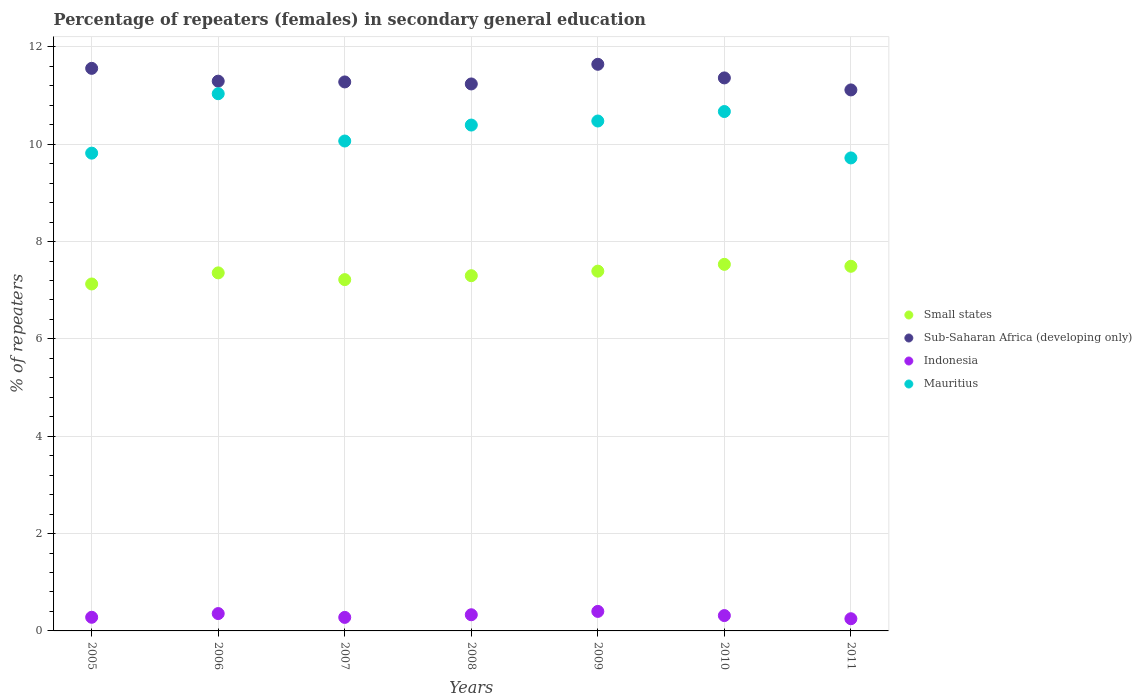Is the number of dotlines equal to the number of legend labels?
Provide a succinct answer. Yes. What is the percentage of female repeaters in Small states in 2005?
Your answer should be compact. 7.13. Across all years, what is the maximum percentage of female repeaters in Sub-Saharan Africa (developing only)?
Your response must be concise. 11.64. Across all years, what is the minimum percentage of female repeaters in Small states?
Make the answer very short. 7.13. In which year was the percentage of female repeaters in Sub-Saharan Africa (developing only) minimum?
Provide a short and direct response. 2011. What is the total percentage of female repeaters in Small states in the graph?
Offer a very short reply. 51.42. What is the difference between the percentage of female repeaters in Sub-Saharan Africa (developing only) in 2009 and that in 2011?
Ensure brevity in your answer.  0.53. What is the difference between the percentage of female repeaters in Small states in 2005 and the percentage of female repeaters in Mauritius in 2010?
Provide a succinct answer. -3.54. What is the average percentage of female repeaters in Mauritius per year?
Keep it short and to the point. 10.31. In the year 2007, what is the difference between the percentage of female repeaters in Small states and percentage of female repeaters in Mauritius?
Your answer should be very brief. -2.85. In how many years, is the percentage of female repeaters in Mauritius greater than 7.6 %?
Your response must be concise. 7. What is the ratio of the percentage of female repeaters in Small states in 2005 to that in 2007?
Give a very brief answer. 0.99. Is the percentage of female repeaters in Sub-Saharan Africa (developing only) in 2005 less than that in 2008?
Ensure brevity in your answer.  No. What is the difference between the highest and the second highest percentage of female repeaters in Sub-Saharan Africa (developing only)?
Make the answer very short. 0.08. What is the difference between the highest and the lowest percentage of female repeaters in Mauritius?
Offer a very short reply. 1.32. In how many years, is the percentage of female repeaters in Mauritius greater than the average percentage of female repeaters in Mauritius taken over all years?
Your response must be concise. 4. Is the percentage of female repeaters in Small states strictly greater than the percentage of female repeaters in Sub-Saharan Africa (developing only) over the years?
Your response must be concise. No. Is the percentage of female repeaters in Mauritius strictly less than the percentage of female repeaters in Indonesia over the years?
Give a very brief answer. No. How many dotlines are there?
Ensure brevity in your answer.  4. How many years are there in the graph?
Provide a succinct answer. 7. Are the values on the major ticks of Y-axis written in scientific E-notation?
Ensure brevity in your answer.  No. How are the legend labels stacked?
Give a very brief answer. Vertical. What is the title of the graph?
Ensure brevity in your answer.  Percentage of repeaters (females) in secondary general education. Does "High income: nonOECD" appear as one of the legend labels in the graph?
Your answer should be very brief. No. What is the label or title of the Y-axis?
Ensure brevity in your answer.  % of repeaters. What is the % of repeaters of Small states in 2005?
Provide a succinct answer. 7.13. What is the % of repeaters in Sub-Saharan Africa (developing only) in 2005?
Give a very brief answer. 11.56. What is the % of repeaters in Indonesia in 2005?
Offer a very short reply. 0.28. What is the % of repeaters of Mauritius in 2005?
Give a very brief answer. 9.82. What is the % of repeaters of Small states in 2006?
Keep it short and to the point. 7.36. What is the % of repeaters of Sub-Saharan Africa (developing only) in 2006?
Offer a very short reply. 11.3. What is the % of repeaters of Indonesia in 2006?
Make the answer very short. 0.36. What is the % of repeaters of Mauritius in 2006?
Ensure brevity in your answer.  11.04. What is the % of repeaters of Small states in 2007?
Make the answer very short. 7.22. What is the % of repeaters of Sub-Saharan Africa (developing only) in 2007?
Offer a terse response. 11.28. What is the % of repeaters in Indonesia in 2007?
Provide a succinct answer. 0.28. What is the % of repeaters in Mauritius in 2007?
Provide a succinct answer. 10.07. What is the % of repeaters in Small states in 2008?
Offer a very short reply. 7.3. What is the % of repeaters in Sub-Saharan Africa (developing only) in 2008?
Provide a short and direct response. 11.24. What is the % of repeaters in Indonesia in 2008?
Provide a short and direct response. 0.33. What is the % of repeaters of Mauritius in 2008?
Provide a succinct answer. 10.39. What is the % of repeaters of Small states in 2009?
Provide a short and direct response. 7.39. What is the % of repeaters of Sub-Saharan Africa (developing only) in 2009?
Offer a terse response. 11.64. What is the % of repeaters of Indonesia in 2009?
Your response must be concise. 0.4. What is the % of repeaters of Mauritius in 2009?
Your answer should be compact. 10.48. What is the % of repeaters of Small states in 2010?
Your response must be concise. 7.53. What is the % of repeaters in Sub-Saharan Africa (developing only) in 2010?
Your answer should be compact. 11.36. What is the % of repeaters of Indonesia in 2010?
Provide a short and direct response. 0.32. What is the % of repeaters in Mauritius in 2010?
Give a very brief answer. 10.67. What is the % of repeaters in Small states in 2011?
Your answer should be very brief. 7.49. What is the % of repeaters of Sub-Saharan Africa (developing only) in 2011?
Provide a short and direct response. 11.12. What is the % of repeaters of Indonesia in 2011?
Offer a very short reply. 0.25. What is the % of repeaters in Mauritius in 2011?
Keep it short and to the point. 9.72. Across all years, what is the maximum % of repeaters of Small states?
Give a very brief answer. 7.53. Across all years, what is the maximum % of repeaters of Sub-Saharan Africa (developing only)?
Your answer should be compact. 11.64. Across all years, what is the maximum % of repeaters in Indonesia?
Make the answer very short. 0.4. Across all years, what is the maximum % of repeaters of Mauritius?
Your answer should be very brief. 11.04. Across all years, what is the minimum % of repeaters of Small states?
Keep it short and to the point. 7.13. Across all years, what is the minimum % of repeaters in Sub-Saharan Africa (developing only)?
Your answer should be compact. 11.12. Across all years, what is the minimum % of repeaters of Indonesia?
Offer a terse response. 0.25. Across all years, what is the minimum % of repeaters of Mauritius?
Your answer should be very brief. 9.72. What is the total % of repeaters in Small states in the graph?
Ensure brevity in your answer.  51.42. What is the total % of repeaters in Sub-Saharan Africa (developing only) in the graph?
Your answer should be compact. 79.5. What is the total % of repeaters of Indonesia in the graph?
Give a very brief answer. 2.21. What is the total % of repeaters in Mauritius in the graph?
Your response must be concise. 72.18. What is the difference between the % of repeaters in Small states in 2005 and that in 2006?
Offer a terse response. -0.23. What is the difference between the % of repeaters in Sub-Saharan Africa (developing only) in 2005 and that in 2006?
Offer a very short reply. 0.26. What is the difference between the % of repeaters in Indonesia in 2005 and that in 2006?
Ensure brevity in your answer.  -0.08. What is the difference between the % of repeaters of Mauritius in 2005 and that in 2006?
Offer a terse response. -1.22. What is the difference between the % of repeaters of Small states in 2005 and that in 2007?
Give a very brief answer. -0.09. What is the difference between the % of repeaters of Sub-Saharan Africa (developing only) in 2005 and that in 2007?
Offer a terse response. 0.28. What is the difference between the % of repeaters of Indonesia in 2005 and that in 2007?
Offer a terse response. 0. What is the difference between the % of repeaters in Mauritius in 2005 and that in 2007?
Offer a terse response. -0.25. What is the difference between the % of repeaters of Small states in 2005 and that in 2008?
Ensure brevity in your answer.  -0.17. What is the difference between the % of repeaters in Sub-Saharan Africa (developing only) in 2005 and that in 2008?
Your answer should be compact. 0.32. What is the difference between the % of repeaters in Indonesia in 2005 and that in 2008?
Offer a terse response. -0.05. What is the difference between the % of repeaters in Mauritius in 2005 and that in 2008?
Ensure brevity in your answer.  -0.58. What is the difference between the % of repeaters of Small states in 2005 and that in 2009?
Offer a terse response. -0.26. What is the difference between the % of repeaters in Sub-Saharan Africa (developing only) in 2005 and that in 2009?
Provide a short and direct response. -0.08. What is the difference between the % of repeaters in Indonesia in 2005 and that in 2009?
Offer a very short reply. -0.12. What is the difference between the % of repeaters in Mauritius in 2005 and that in 2009?
Offer a terse response. -0.66. What is the difference between the % of repeaters of Small states in 2005 and that in 2010?
Offer a very short reply. -0.4. What is the difference between the % of repeaters in Sub-Saharan Africa (developing only) in 2005 and that in 2010?
Keep it short and to the point. 0.2. What is the difference between the % of repeaters of Indonesia in 2005 and that in 2010?
Offer a terse response. -0.03. What is the difference between the % of repeaters in Mauritius in 2005 and that in 2010?
Make the answer very short. -0.86. What is the difference between the % of repeaters of Small states in 2005 and that in 2011?
Your response must be concise. -0.36. What is the difference between the % of repeaters of Sub-Saharan Africa (developing only) in 2005 and that in 2011?
Your response must be concise. 0.44. What is the difference between the % of repeaters in Indonesia in 2005 and that in 2011?
Offer a terse response. 0.03. What is the difference between the % of repeaters in Mauritius in 2005 and that in 2011?
Your answer should be compact. 0.1. What is the difference between the % of repeaters in Small states in 2006 and that in 2007?
Provide a succinct answer. 0.14. What is the difference between the % of repeaters of Sub-Saharan Africa (developing only) in 2006 and that in 2007?
Provide a short and direct response. 0.02. What is the difference between the % of repeaters in Indonesia in 2006 and that in 2007?
Your answer should be compact. 0.08. What is the difference between the % of repeaters in Small states in 2006 and that in 2008?
Your answer should be compact. 0.06. What is the difference between the % of repeaters of Sub-Saharan Africa (developing only) in 2006 and that in 2008?
Keep it short and to the point. 0.06. What is the difference between the % of repeaters in Indonesia in 2006 and that in 2008?
Make the answer very short. 0.02. What is the difference between the % of repeaters in Mauritius in 2006 and that in 2008?
Offer a very short reply. 0.64. What is the difference between the % of repeaters in Small states in 2006 and that in 2009?
Your answer should be very brief. -0.04. What is the difference between the % of repeaters of Sub-Saharan Africa (developing only) in 2006 and that in 2009?
Provide a succinct answer. -0.35. What is the difference between the % of repeaters in Indonesia in 2006 and that in 2009?
Offer a very short reply. -0.04. What is the difference between the % of repeaters of Mauritius in 2006 and that in 2009?
Your response must be concise. 0.56. What is the difference between the % of repeaters in Small states in 2006 and that in 2010?
Offer a terse response. -0.18. What is the difference between the % of repeaters of Sub-Saharan Africa (developing only) in 2006 and that in 2010?
Your answer should be compact. -0.07. What is the difference between the % of repeaters of Indonesia in 2006 and that in 2010?
Ensure brevity in your answer.  0.04. What is the difference between the % of repeaters in Mauritius in 2006 and that in 2010?
Provide a succinct answer. 0.37. What is the difference between the % of repeaters of Small states in 2006 and that in 2011?
Offer a very short reply. -0.14. What is the difference between the % of repeaters in Sub-Saharan Africa (developing only) in 2006 and that in 2011?
Offer a very short reply. 0.18. What is the difference between the % of repeaters in Indonesia in 2006 and that in 2011?
Give a very brief answer. 0.11. What is the difference between the % of repeaters in Mauritius in 2006 and that in 2011?
Provide a succinct answer. 1.32. What is the difference between the % of repeaters in Small states in 2007 and that in 2008?
Offer a terse response. -0.08. What is the difference between the % of repeaters in Sub-Saharan Africa (developing only) in 2007 and that in 2008?
Your response must be concise. 0.04. What is the difference between the % of repeaters in Indonesia in 2007 and that in 2008?
Provide a short and direct response. -0.05. What is the difference between the % of repeaters in Mauritius in 2007 and that in 2008?
Offer a very short reply. -0.33. What is the difference between the % of repeaters in Small states in 2007 and that in 2009?
Ensure brevity in your answer.  -0.17. What is the difference between the % of repeaters in Sub-Saharan Africa (developing only) in 2007 and that in 2009?
Give a very brief answer. -0.36. What is the difference between the % of repeaters of Indonesia in 2007 and that in 2009?
Offer a terse response. -0.12. What is the difference between the % of repeaters of Mauritius in 2007 and that in 2009?
Make the answer very short. -0.41. What is the difference between the % of repeaters in Small states in 2007 and that in 2010?
Make the answer very short. -0.31. What is the difference between the % of repeaters in Sub-Saharan Africa (developing only) in 2007 and that in 2010?
Provide a succinct answer. -0.08. What is the difference between the % of repeaters in Indonesia in 2007 and that in 2010?
Your response must be concise. -0.04. What is the difference between the % of repeaters of Mauritius in 2007 and that in 2010?
Provide a short and direct response. -0.61. What is the difference between the % of repeaters of Small states in 2007 and that in 2011?
Provide a short and direct response. -0.27. What is the difference between the % of repeaters in Sub-Saharan Africa (developing only) in 2007 and that in 2011?
Provide a succinct answer. 0.16. What is the difference between the % of repeaters of Indonesia in 2007 and that in 2011?
Your response must be concise. 0.03. What is the difference between the % of repeaters of Mauritius in 2007 and that in 2011?
Your answer should be very brief. 0.35. What is the difference between the % of repeaters of Small states in 2008 and that in 2009?
Make the answer very short. -0.09. What is the difference between the % of repeaters in Sub-Saharan Africa (developing only) in 2008 and that in 2009?
Give a very brief answer. -0.4. What is the difference between the % of repeaters in Indonesia in 2008 and that in 2009?
Keep it short and to the point. -0.07. What is the difference between the % of repeaters in Mauritius in 2008 and that in 2009?
Provide a short and direct response. -0.08. What is the difference between the % of repeaters in Small states in 2008 and that in 2010?
Make the answer very short. -0.23. What is the difference between the % of repeaters in Sub-Saharan Africa (developing only) in 2008 and that in 2010?
Provide a succinct answer. -0.12. What is the difference between the % of repeaters of Indonesia in 2008 and that in 2010?
Make the answer very short. 0.02. What is the difference between the % of repeaters in Mauritius in 2008 and that in 2010?
Offer a terse response. -0.28. What is the difference between the % of repeaters in Small states in 2008 and that in 2011?
Offer a terse response. -0.19. What is the difference between the % of repeaters in Sub-Saharan Africa (developing only) in 2008 and that in 2011?
Your answer should be compact. 0.12. What is the difference between the % of repeaters of Indonesia in 2008 and that in 2011?
Ensure brevity in your answer.  0.08. What is the difference between the % of repeaters of Mauritius in 2008 and that in 2011?
Provide a short and direct response. 0.68. What is the difference between the % of repeaters in Small states in 2009 and that in 2010?
Your answer should be compact. -0.14. What is the difference between the % of repeaters of Sub-Saharan Africa (developing only) in 2009 and that in 2010?
Your answer should be compact. 0.28. What is the difference between the % of repeaters in Indonesia in 2009 and that in 2010?
Your response must be concise. 0.09. What is the difference between the % of repeaters of Mauritius in 2009 and that in 2010?
Offer a very short reply. -0.19. What is the difference between the % of repeaters in Small states in 2009 and that in 2011?
Your answer should be very brief. -0.1. What is the difference between the % of repeaters of Sub-Saharan Africa (developing only) in 2009 and that in 2011?
Your response must be concise. 0.53. What is the difference between the % of repeaters of Indonesia in 2009 and that in 2011?
Provide a short and direct response. 0.15. What is the difference between the % of repeaters of Mauritius in 2009 and that in 2011?
Provide a succinct answer. 0.76. What is the difference between the % of repeaters in Sub-Saharan Africa (developing only) in 2010 and that in 2011?
Keep it short and to the point. 0.25. What is the difference between the % of repeaters of Indonesia in 2010 and that in 2011?
Give a very brief answer. 0.06. What is the difference between the % of repeaters in Mauritius in 2010 and that in 2011?
Your answer should be compact. 0.95. What is the difference between the % of repeaters in Small states in 2005 and the % of repeaters in Sub-Saharan Africa (developing only) in 2006?
Your answer should be compact. -4.17. What is the difference between the % of repeaters in Small states in 2005 and the % of repeaters in Indonesia in 2006?
Offer a very short reply. 6.77. What is the difference between the % of repeaters in Small states in 2005 and the % of repeaters in Mauritius in 2006?
Offer a terse response. -3.91. What is the difference between the % of repeaters in Sub-Saharan Africa (developing only) in 2005 and the % of repeaters in Indonesia in 2006?
Keep it short and to the point. 11.2. What is the difference between the % of repeaters of Sub-Saharan Africa (developing only) in 2005 and the % of repeaters of Mauritius in 2006?
Make the answer very short. 0.52. What is the difference between the % of repeaters of Indonesia in 2005 and the % of repeaters of Mauritius in 2006?
Make the answer very short. -10.76. What is the difference between the % of repeaters of Small states in 2005 and the % of repeaters of Sub-Saharan Africa (developing only) in 2007?
Keep it short and to the point. -4.15. What is the difference between the % of repeaters in Small states in 2005 and the % of repeaters in Indonesia in 2007?
Your response must be concise. 6.85. What is the difference between the % of repeaters of Small states in 2005 and the % of repeaters of Mauritius in 2007?
Provide a succinct answer. -2.94. What is the difference between the % of repeaters of Sub-Saharan Africa (developing only) in 2005 and the % of repeaters of Indonesia in 2007?
Make the answer very short. 11.28. What is the difference between the % of repeaters of Sub-Saharan Africa (developing only) in 2005 and the % of repeaters of Mauritius in 2007?
Provide a short and direct response. 1.49. What is the difference between the % of repeaters in Indonesia in 2005 and the % of repeaters in Mauritius in 2007?
Provide a succinct answer. -9.79. What is the difference between the % of repeaters of Small states in 2005 and the % of repeaters of Sub-Saharan Africa (developing only) in 2008?
Offer a terse response. -4.11. What is the difference between the % of repeaters in Small states in 2005 and the % of repeaters in Indonesia in 2008?
Keep it short and to the point. 6.8. What is the difference between the % of repeaters of Small states in 2005 and the % of repeaters of Mauritius in 2008?
Your answer should be compact. -3.27. What is the difference between the % of repeaters of Sub-Saharan Africa (developing only) in 2005 and the % of repeaters of Indonesia in 2008?
Provide a succinct answer. 11.23. What is the difference between the % of repeaters of Sub-Saharan Africa (developing only) in 2005 and the % of repeaters of Mauritius in 2008?
Give a very brief answer. 1.17. What is the difference between the % of repeaters of Indonesia in 2005 and the % of repeaters of Mauritius in 2008?
Provide a succinct answer. -10.11. What is the difference between the % of repeaters of Small states in 2005 and the % of repeaters of Sub-Saharan Africa (developing only) in 2009?
Provide a short and direct response. -4.51. What is the difference between the % of repeaters in Small states in 2005 and the % of repeaters in Indonesia in 2009?
Ensure brevity in your answer.  6.73. What is the difference between the % of repeaters in Small states in 2005 and the % of repeaters in Mauritius in 2009?
Your response must be concise. -3.35. What is the difference between the % of repeaters of Sub-Saharan Africa (developing only) in 2005 and the % of repeaters of Indonesia in 2009?
Your answer should be very brief. 11.16. What is the difference between the % of repeaters in Sub-Saharan Africa (developing only) in 2005 and the % of repeaters in Mauritius in 2009?
Ensure brevity in your answer.  1.08. What is the difference between the % of repeaters of Indonesia in 2005 and the % of repeaters of Mauritius in 2009?
Provide a succinct answer. -10.2. What is the difference between the % of repeaters in Small states in 2005 and the % of repeaters in Sub-Saharan Africa (developing only) in 2010?
Your answer should be very brief. -4.23. What is the difference between the % of repeaters in Small states in 2005 and the % of repeaters in Indonesia in 2010?
Your answer should be compact. 6.81. What is the difference between the % of repeaters in Small states in 2005 and the % of repeaters in Mauritius in 2010?
Ensure brevity in your answer.  -3.54. What is the difference between the % of repeaters in Sub-Saharan Africa (developing only) in 2005 and the % of repeaters in Indonesia in 2010?
Offer a very short reply. 11.24. What is the difference between the % of repeaters of Sub-Saharan Africa (developing only) in 2005 and the % of repeaters of Mauritius in 2010?
Provide a short and direct response. 0.89. What is the difference between the % of repeaters in Indonesia in 2005 and the % of repeaters in Mauritius in 2010?
Offer a very short reply. -10.39. What is the difference between the % of repeaters in Small states in 2005 and the % of repeaters in Sub-Saharan Africa (developing only) in 2011?
Your response must be concise. -3.99. What is the difference between the % of repeaters of Small states in 2005 and the % of repeaters of Indonesia in 2011?
Offer a terse response. 6.88. What is the difference between the % of repeaters of Small states in 2005 and the % of repeaters of Mauritius in 2011?
Offer a terse response. -2.59. What is the difference between the % of repeaters in Sub-Saharan Africa (developing only) in 2005 and the % of repeaters in Indonesia in 2011?
Make the answer very short. 11.31. What is the difference between the % of repeaters in Sub-Saharan Africa (developing only) in 2005 and the % of repeaters in Mauritius in 2011?
Your response must be concise. 1.84. What is the difference between the % of repeaters in Indonesia in 2005 and the % of repeaters in Mauritius in 2011?
Provide a succinct answer. -9.44. What is the difference between the % of repeaters of Small states in 2006 and the % of repeaters of Sub-Saharan Africa (developing only) in 2007?
Provide a succinct answer. -3.92. What is the difference between the % of repeaters of Small states in 2006 and the % of repeaters of Indonesia in 2007?
Keep it short and to the point. 7.08. What is the difference between the % of repeaters in Small states in 2006 and the % of repeaters in Mauritius in 2007?
Make the answer very short. -2.71. What is the difference between the % of repeaters of Sub-Saharan Africa (developing only) in 2006 and the % of repeaters of Indonesia in 2007?
Provide a succinct answer. 11.02. What is the difference between the % of repeaters of Sub-Saharan Africa (developing only) in 2006 and the % of repeaters of Mauritius in 2007?
Provide a succinct answer. 1.23. What is the difference between the % of repeaters in Indonesia in 2006 and the % of repeaters in Mauritius in 2007?
Your answer should be compact. -9.71. What is the difference between the % of repeaters in Small states in 2006 and the % of repeaters in Sub-Saharan Africa (developing only) in 2008?
Make the answer very short. -3.88. What is the difference between the % of repeaters of Small states in 2006 and the % of repeaters of Indonesia in 2008?
Ensure brevity in your answer.  7.02. What is the difference between the % of repeaters of Small states in 2006 and the % of repeaters of Mauritius in 2008?
Give a very brief answer. -3.04. What is the difference between the % of repeaters of Sub-Saharan Africa (developing only) in 2006 and the % of repeaters of Indonesia in 2008?
Offer a very short reply. 10.96. What is the difference between the % of repeaters in Sub-Saharan Africa (developing only) in 2006 and the % of repeaters in Mauritius in 2008?
Offer a terse response. 0.9. What is the difference between the % of repeaters in Indonesia in 2006 and the % of repeaters in Mauritius in 2008?
Offer a terse response. -10.04. What is the difference between the % of repeaters in Small states in 2006 and the % of repeaters in Sub-Saharan Africa (developing only) in 2009?
Ensure brevity in your answer.  -4.29. What is the difference between the % of repeaters in Small states in 2006 and the % of repeaters in Indonesia in 2009?
Offer a very short reply. 6.96. What is the difference between the % of repeaters of Small states in 2006 and the % of repeaters of Mauritius in 2009?
Your answer should be compact. -3.12. What is the difference between the % of repeaters of Sub-Saharan Africa (developing only) in 2006 and the % of repeaters of Indonesia in 2009?
Your answer should be very brief. 10.89. What is the difference between the % of repeaters in Sub-Saharan Africa (developing only) in 2006 and the % of repeaters in Mauritius in 2009?
Offer a terse response. 0.82. What is the difference between the % of repeaters of Indonesia in 2006 and the % of repeaters of Mauritius in 2009?
Your response must be concise. -10.12. What is the difference between the % of repeaters in Small states in 2006 and the % of repeaters in Sub-Saharan Africa (developing only) in 2010?
Make the answer very short. -4.01. What is the difference between the % of repeaters in Small states in 2006 and the % of repeaters in Indonesia in 2010?
Ensure brevity in your answer.  7.04. What is the difference between the % of repeaters of Small states in 2006 and the % of repeaters of Mauritius in 2010?
Ensure brevity in your answer.  -3.32. What is the difference between the % of repeaters in Sub-Saharan Africa (developing only) in 2006 and the % of repeaters in Indonesia in 2010?
Ensure brevity in your answer.  10.98. What is the difference between the % of repeaters in Sub-Saharan Africa (developing only) in 2006 and the % of repeaters in Mauritius in 2010?
Offer a very short reply. 0.62. What is the difference between the % of repeaters of Indonesia in 2006 and the % of repeaters of Mauritius in 2010?
Your answer should be very brief. -10.32. What is the difference between the % of repeaters in Small states in 2006 and the % of repeaters in Sub-Saharan Africa (developing only) in 2011?
Your answer should be very brief. -3.76. What is the difference between the % of repeaters of Small states in 2006 and the % of repeaters of Indonesia in 2011?
Your answer should be very brief. 7.11. What is the difference between the % of repeaters in Small states in 2006 and the % of repeaters in Mauritius in 2011?
Keep it short and to the point. -2.36. What is the difference between the % of repeaters of Sub-Saharan Africa (developing only) in 2006 and the % of repeaters of Indonesia in 2011?
Give a very brief answer. 11.05. What is the difference between the % of repeaters in Sub-Saharan Africa (developing only) in 2006 and the % of repeaters in Mauritius in 2011?
Your answer should be very brief. 1.58. What is the difference between the % of repeaters of Indonesia in 2006 and the % of repeaters of Mauritius in 2011?
Ensure brevity in your answer.  -9.36. What is the difference between the % of repeaters of Small states in 2007 and the % of repeaters of Sub-Saharan Africa (developing only) in 2008?
Give a very brief answer. -4.02. What is the difference between the % of repeaters in Small states in 2007 and the % of repeaters in Indonesia in 2008?
Provide a short and direct response. 6.89. What is the difference between the % of repeaters of Small states in 2007 and the % of repeaters of Mauritius in 2008?
Your answer should be compact. -3.18. What is the difference between the % of repeaters in Sub-Saharan Africa (developing only) in 2007 and the % of repeaters in Indonesia in 2008?
Make the answer very short. 10.95. What is the difference between the % of repeaters in Sub-Saharan Africa (developing only) in 2007 and the % of repeaters in Mauritius in 2008?
Your answer should be compact. 0.89. What is the difference between the % of repeaters of Indonesia in 2007 and the % of repeaters of Mauritius in 2008?
Provide a succinct answer. -10.12. What is the difference between the % of repeaters in Small states in 2007 and the % of repeaters in Sub-Saharan Africa (developing only) in 2009?
Keep it short and to the point. -4.42. What is the difference between the % of repeaters of Small states in 2007 and the % of repeaters of Indonesia in 2009?
Give a very brief answer. 6.82. What is the difference between the % of repeaters of Small states in 2007 and the % of repeaters of Mauritius in 2009?
Your response must be concise. -3.26. What is the difference between the % of repeaters of Sub-Saharan Africa (developing only) in 2007 and the % of repeaters of Indonesia in 2009?
Offer a terse response. 10.88. What is the difference between the % of repeaters in Sub-Saharan Africa (developing only) in 2007 and the % of repeaters in Mauritius in 2009?
Provide a succinct answer. 0.8. What is the difference between the % of repeaters of Indonesia in 2007 and the % of repeaters of Mauritius in 2009?
Your response must be concise. -10.2. What is the difference between the % of repeaters in Small states in 2007 and the % of repeaters in Sub-Saharan Africa (developing only) in 2010?
Offer a terse response. -4.14. What is the difference between the % of repeaters of Small states in 2007 and the % of repeaters of Indonesia in 2010?
Ensure brevity in your answer.  6.9. What is the difference between the % of repeaters in Small states in 2007 and the % of repeaters in Mauritius in 2010?
Provide a succinct answer. -3.45. What is the difference between the % of repeaters in Sub-Saharan Africa (developing only) in 2007 and the % of repeaters in Indonesia in 2010?
Offer a very short reply. 10.96. What is the difference between the % of repeaters of Sub-Saharan Africa (developing only) in 2007 and the % of repeaters of Mauritius in 2010?
Give a very brief answer. 0.61. What is the difference between the % of repeaters in Indonesia in 2007 and the % of repeaters in Mauritius in 2010?
Offer a terse response. -10.39. What is the difference between the % of repeaters of Small states in 2007 and the % of repeaters of Sub-Saharan Africa (developing only) in 2011?
Provide a succinct answer. -3.9. What is the difference between the % of repeaters of Small states in 2007 and the % of repeaters of Indonesia in 2011?
Provide a short and direct response. 6.97. What is the difference between the % of repeaters in Small states in 2007 and the % of repeaters in Mauritius in 2011?
Ensure brevity in your answer.  -2.5. What is the difference between the % of repeaters in Sub-Saharan Africa (developing only) in 2007 and the % of repeaters in Indonesia in 2011?
Give a very brief answer. 11.03. What is the difference between the % of repeaters in Sub-Saharan Africa (developing only) in 2007 and the % of repeaters in Mauritius in 2011?
Your response must be concise. 1.56. What is the difference between the % of repeaters of Indonesia in 2007 and the % of repeaters of Mauritius in 2011?
Provide a short and direct response. -9.44. What is the difference between the % of repeaters of Small states in 2008 and the % of repeaters of Sub-Saharan Africa (developing only) in 2009?
Your response must be concise. -4.34. What is the difference between the % of repeaters in Small states in 2008 and the % of repeaters in Indonesia in 2009?
Your response must be concise. 6.9. What is the difference between the % of repeaters of Small states in 2008 and the % of repeaters of Mauritius in 2009?
Keep it short and to the point. -3.18. What is the difference between the % of repeaters of Sub-Saharan Africa (developing only) in 2008 and the % of repeaters of Indonesia in 2009?
Your response must be concise. 10.84. What is the difference between the % of repeaters in Sub-Saharan Africa (developing only) in 2008 and the % of repeaters in Mauritius in 2009?
Offer a terse response. 0.76. What is the difference between the % of repeaters of Indonesia in 2008 and the % of repeaters of Mauritius in 2009?
Your answer should be very brief. -10.15. What is the difference between the % of repeaters in Small states in 2008 and the % of repeaters in Sub-Saharan Africa (developing only) in 2010?
Your answer should be very brief. -4.06. What is the difference between the % of repeaters of Small states in 2008 and the % of repeaters of Indonesia in 2010?
Give a very brief answer. 6.98. What is the difference between the % of repeaters in Small states in 2008 and the % of repeaters in Mauritius in 2010?
Your answer should be compact. -3.37. What is the difference between the % of repeaters in Sub-Saharan Africa (developing only) in 2008 and the % of repeaters in Indonesia in 2010?
Give a very brief answer. 10.92. What is the difference between the % of repeaters in Sub-Saharan Africa (developing only) in 2008 and the % of repeaters in Mauritius in 2010?
Offer a terse response. 0.57. What is the difference between the % of repeaters in Indonesia in 2008 and the % of repeaters in Mauritius in 2010?
Give a very brief answer. -10.34. What is the difference between the % of repeaters in Small states in 2008 and the % of repeaters in Sub-Saharan Africa (developing only) in 2011?
Keep it short and to the point. -3.82. What is the difference between the % of repeaters in Small states in 2008 and the % of repeaters in Indonesia in 2011?
Provide a succinct answer. 7.05. What is the difference between the % of repeaters in Small states in 2008 and the % of repeaters in Mauritius in 2011?
Offer a terse response. -2.42. What is the difference between the % of repeaters of Sub-Saharan Africa (developing only) in 2008 and the % of repeaters of Indonesia in 2011?
Provide a succinct answer. 10.99. What is the difference between the % of repeaters of Sub-Saharan Africa (developing only) in 2008 and the % of repeaters of Mauritius in 2011?
Provide a short and direct response. 1.52. What is the difference between the % of repeaters in Indonesia in 2008 and the % of repeaters in Mauritius in 2011?
Your response must be concise. -9.39. What is the difference between the % of repeaters of Small states in 2009 and the % of repeaters of Sub-Saharan Africa (developing only) in 2010?
Keep it short and to the point. -3.97. What is the difference between the % of repeaters of Small states in 2009 and the % of repeaters of Indonesia in 2010?
Your answer should be compact. 7.08. What is the difference between the % of repeaters of Small states in 2009 and the % of repeaters of Mauritius in 2010?
Offer a very short reply. -3.28. What is the difference between the % of repeaters of Sub-Saharan Africa (developing only) in 2009 and the % of repeaters of Indonesia in 2010?
Ensure brevity in your answer.  11.33. What is the difference between the % of repeaters in Sub-Saharan Africa (developing only) in 2009 and the % of repeaters in Mauritius in 2010?
Offer a very short reply. 0.97. What is the difference between the % of repeaters in Indonesia in 2009 and the % of repeaters in Mauritius in 2010?
Make the answer very short. -10.27. What is the difference between the % of repeaters of Small states in 2009 and the % of repeaters of Sub-Saharan Africa (developing only) in 2011?
Give a very brief answer. -3.72. What is the difference between the % of repeaters of Small states in 2009 and the % of repeaters of Indonesia in 2011?
Provide a succinct answer. 7.14. What is the difference between the % of repeaters of Small states in 2009 and the % of repeaters of Mauritius in 2011?
Keep it short and to the point. -2.33. What is the difference between the % of repeaters in Sub-Saharan Africa (developing only) in 2009 and the % of repeaters in Indonesia in 2011?
Your answer should be compact. 11.39. What is the difference between the % of repeaters of Sub-Saharan Africa (developing only) in 2009 and the % of repeaters of Mauritius in 2011?
Your response must be concise. 1.92. What is the difference between the % of repeaters of Indonesia in 2009 and the % of repeaters of Mauritius in 2011?
Provide a short and direct response. -9.32. What is the difference between the % of repeaters in Small states in 2010 and the % of repeaters in Sub-Saharan Africa (developing only) in 2011?
Make the answer very short. -3.58. What is the difference between the % of repeaters of Small states in 2010 and the % of repeaters of Indonesia in 2011?
Make the answer very short. 7.28. What is the difference between the % of repeaters in Small states in 2010 and the % of repeaters in Mauritius in 2011?
Your response must be concise. -2.19. What is the difference between the % of repeaters in Sub-Saharan Africa (developing only) in 2010 and the % of repeaters in Indonesia in 2011?
Your answer should be very brief. 11.11. What is the difference between the % of repeaters of Sub-Saharan Africa (developing only) in 2010 and the % of repeaters of Mauritius in 2011?
Ensure brevity in your answer.  1.64. What is the difference between the % of repeaters of Indonesia in 2010 and the % of repeaters of Mauritius in 2011?
Your answer should be compact. -9.4. What is the average % of repeaters of Small states per year?
Keep it short and to the point. 7.35. What is the average % of repeaters in Sub-Saharan Africa (developing only) per year?
Offer a very short reply. 11.36. What is the average % of repeaters of Indonesia per year?
Your answer should be compact. 0.32. What is the average % of repeaters in Mauritius per year?
Your response must be concise. 10.31. In the year 2005, what is the difference between the % of repeaters in Small states and % of repeaters in Sub-Saharan Africa (developing only)?
Your answer should be compact. -4.43. In the year 2005, what is the difference between the % of repeaters in Small states and % of repeaters in Indonesia?
Make the answer very short. 6.85. In the year 2005, what is the difference between the % of repeaters in Small states and % of repeaters in Mauritius?
Offer a terse response. -2.69. In the year 2005, what is the difference between the % of repeaters in Sub-Saharan Africa (developing only) and % of repeaters in Indonesia?
Offer a very short reply. 11.28. In the year 2005, what is the difference between the % of repeaters in Sub-Saharan Africa (developing only) and % of repeaters in Mauritius?
Provide a short and direct response. 1.74. In the year 2005, what is the difference between the % of repeaters in Indonesia and % of repeaters in Mauritius?
Provide a succinct answer. -9.54. In the year 2006, what is the difference between the % of repeaters of Small states and % of repeaters of Sub-Saharan Africa (developing only)?
Offer a terse response. -3.94. In the year 2006, what is the difference between the % of repeaters of Small states and % of repeaters of Indonesia?
Your response must be concise. 7. In the year 2006, what is the difference between the % of repeaters of Small states and % of repeaters of Mauritius?
Make the answer very short. -3.68. In the year 2006, what is the difference between the % of repeaters of Sub-Saharan Africa (developing only) and % of repeaters of Indonesia?
Make the answer very short. 10.94. In the year 2006, what is the difference between the % of repeaters in Sub-Saharan Africa (developing only) and % of repeaters in Mauritius?
Make the answer very short. 0.26. In the year 2006, what is the difference between the % of repeaters in Indonesia and % of repeaters in Mauritius?
Give a very brief answer. -10.68. In the year 2007, what is the difference between the % of repeaters of Small states and % of repeaters of Sub-Saharan Africa (developing only)?
Ensure brevity in your answer.  -4.06. In the year 2007, what is the difference between the % of repeaters in Small states and % of repeaters in Indonesia?
Provide a short and direct response. 6.94. In the year 2007, what is the difference between the % of repeaters in Small states and % of repeaters in Mauritius?
Give a very brief answer. -2.85. In the year 2007, what is the difference between the % of repeaters of Sub-Saharan Africa (developing only) and % of repeaters of Indonesia?
Your answer should be very brief. 11. In the year 2007, what is the difference between the % of repeaters of Sub-Saharan Africa (developing only) and % of repeaters of Mauritius?
Your response must be concise. 1.21. In the year 2007, what is the difference between the % of repeaters of Indonesia and % of repeaters of Mauritius?
Your answer should be compact. -9.79. In the year 2008, what is the difference between the % of repeaters of Small states and % of repeaters of Sub-Saharan Africa (developing only)?
Make the answer very short. -3.94. In the year 2008, what is the difference between the % of repeaters of Small states and % of repeaters of Indonesia?
Provide a succinct answer. 6.97. In the year 2008, what is the difference between the % of repeaters of Small states and % of repeaters of Mauritius?
Give a very brief answer. -3.1. In the year 2008, what is the difference between the % of repeaters in Sub-Saharan Africa (developing only) and % of repeaters in Indonesia?
Provide a succinct answer. 10.91. In the year 2008, what is the difference between the % of repeaters of Sub-Saharan Africa (developing only) and % of repeaters of Mauritius?
Give a very brief answer. 0.84. In the year 2008, what is the difference between the % of repeaters of Indonesia and % of repeaters of Mauritius?
Provide a short and direct response. -10.06. In the year 2009, what is the difference between the % of repeaters of Small states and % of repeaters of Sub-Saharan Africa (developing only)?
Offer a terse response. -4.25. In the year 2009, what is the difference between the % of repeaters of Small states and % of repeaters of Indonesia?
Offer a very short reply. 6.99. In the year 2009, what is the difference between the % of repeaters of Small states and % of repeaters of Mauritius?
Your answer should be very brief. -3.08. In the year 2009, what is the difference between the % of repeaters in Sub-Saharan Africa (developing only) and % of repeaters in Indonesia?
Give a very brief answer. 11.24. In the year 2009, what is the difference between the % of repeaters in Sub-Saharan Africa (developing only) and % of repeaters in Mauritius?
Keep it short and to the point. 1.17. In the year 2009, what is the difference between the % of repeaters in Indonesia and % of repeaters in Mauritius?
Your answer should be very brief. -10.08. In the year 2010, what is the difference between the % of repeaters of Small states and % of repeaters of Sub-Saharan Africa (developing only)?
Provide a short and direct response. -3.83. In the year 2010, what is the difference between the % of repeaters of Small states and % of repeaters of Indonesia?
Provide a succinct answer. 7.22. In the year 2010, what is the difference between the % of repeaters in Small states and % of repeaters in Mauritius?
Provide a succinct answer. -3.14. In the year 2010, what is the difference between the % of repeaters in Sub-Saharan Africa (developing only) and % of repeaters in Indonesia?
Keep it short and to the point. 11.05. In the year 2010, what is the difference between the % of repeaters in Sub-Saharan Africa (developing only) and % of repeaters in Mauritius?
Keep it short and to the point. 0.69. In the year 2010, what is the difference between the % of repeaters of Indonesia and % of repeaters of Mauritius?
Your answer should be very brief. -10.36. In the year 2011, what is the difference between the % of repeaters of Small states and % of repeaters of Sub-Saharan Africa (developing only)?
Your answer should be very brief. -3.62. In the year 2011, what is the difference between the % of repeaters in Small states and % of repeaters in Indonesia?
Provide a succinct answer. 7.24. In the year 2011, what is the difference between the % of repeaters in Small states and % of repeaters in Mauritius?
Your answer should be compact. -2.23. In the year 2011, what is the difference between the % of repeaters of Sub-Saharan Africa (developing only) and % of repeaters of Indonesia?
Offer a terse response. 10.87. In the year 2011, what is the difference between the % of repeaters of Sub-Saharan Africa (developing only) and % of repeaters of Mauritius?
Provide a succinct answer. 1.4. In the year 2011, what is the difference between the % of repeaters of Indonesia and % of repeaters of Mauritius?
Make the answer very short. -9.47. What is the ratio of the % of repeaters of Sub-Saharan Africa (developing only) in 2005 to that in 2006?
Offer a terse response. 1.02. What is the ratio of the % of repeaters of Indonesia in 2005 to that in 2006?
Offer a very short reply. 0.79. What is the ratio of the % of repeaters of Mauritius in 2005 to that in 2006?
Give a very brief answer. 0.89. What is the ratio of the % of repeaters in Small states in 2005 to that in 2007?
Offer a terse response. 0.99. What is the ratio of the % of repeaters in Sub-Saharan Africa (developing only) in 2005 to that in 2007?
Provide a short and direct response. 1.02. What is the ratio of the % of repeaters in Indonesia in 2005 to that in 2007?
Provide a succinct answer. 1.01. What is the ratio of the % of repeaters of Mauritius in 2005 to that in 2007?
Offer a very short reply. 0.98. What is the ratio of the % of repeaters of Small states in 2005 to that in 2008?
Ensure brevity in your answer.  0.98. What is the ratio of the % of repeaters of Sub-Saharan Africa (developing only) in 2005 to that in 2008?
Keep it short and to the point. 1.03. What is the ratio of the % of repeaters of Indonesia in 2005 to that in 2008?
Offer a terse response. 0.84. What is the ratio of the % of repeaters in Mauritius in 2005 to that in 2008?
Your answer should be compact. 0.94. What is the ratio of the % of repeaters of Sub-Saharan Africa (developing only) in 2005 to that in 2009?
Offer a terse response. 0.99. What is the ratio of the % of repeaters of Indonesia in 2005 to that in 2009?
Make the answer very short. 0.7. What is the ratio of the % of repeaters of Mauritius in 2005 to that in 2009?
Offer a terse response. 0.94. What is the ratio of the % of repeaters of Small states in 2005 to that in 2010?
Your answer should be compact. 0.95. What is the ratio of the % of repeaters in Sub-Saharan Africa (developing only) in 2005 to that in 2010?
Offer a terse response. 1.02. What is the ratio of the % of repeaters of Indonesia in 2005 to that in 2010?
Provide a succinct answer. 0.89. What is the ratio of the % of repeaters in Mauritius in 2005 to that in 2010?
Provide a succinct answer. 0.92. What is the ratio of the % of repeaters of Small states in 2005 to that in 2011?
Offer a terse response. 0.95. What is the ratio of the % of repeaters in Sub-Saharan Africa (developing only) in 2005 to that in 2011?
Keep it short and to the point. 1.04. What is the ratio of the % of repeaters of Indonesia in 2005 to that in 2011?
Offer a very short reply. 1.12. What is the ratio of the % of repeaters of Mauritius in 2005 to that in 2011?
Keep it short and to the point. 1.01. What is the ratio of the % of repeaters of Small states in 2006 to that in 2007?
Give a very brief answer. 1.02. What is the ratio of the % of repeaters of Sub-Saharan Africa (developing only) in 2006 to that in 2007?
Offer a very short reply. 1. What is the ratio of the % of repeaters of Indonesia in 2006 to that in 2007?
Your answer should be compact. 1.28. What is the ratio of the % of repeaters of Mauritius in 2006 to that in 2007?
Offer a terse response. 1.1. What is the ratio of the % of repeaters of Small states in 2006 to that in 2008?
Keep it short and to the point. 1.01. What is the ratio of the % of repeaters of Sub-Saharan Africa (developing only) in 2006 to that in 2008?
Your answer should be very brief. 1.01. What is the ratio of the % of repeaters in Indonesia in 2006 to that in 2008?
Your answer should be compact. 1.07. What is the ratio of the % of repeaters in Mauritius in 2006 to that in 2008?
Your answer should be compact. 1.06. What is the ratio of the % of repeaters of Small states in 2006 to that in 2009?
Give a very brief answer. 1. What is the ratio of the % of repeaters in Sub-Saharan Africa (developing only) in 2006 to that in 2009?
Offer a terse response. 0.97. What is the ratio of the % of repeaters of Indonesia in 2006 to that in 2009?
Your answer should be very brief. 0.89. What is the ratio of the % of repeaters in Mauritius in 2006 to that in 2009?
Provide a short and direct response. 1.05. What is the ratio of the % of repeaters in Small states in 2006 to that in 2010?
Ensure brevity in your answer.  0.98. What is the ratio of the % of repeaters of Indonesia in 2006 to that in 2010?
Make the answer very short. 1.13. What is the ratio of the % of repeaters of Mauritius in 2006 to that in 2010?
Ensure brevity in your answer.  1.03. What is the ratio of the % of repeaters of Small states in 2006 to that in 2011?
Ensure brevity in your answer.  0.98. What is the ratio of the % of repeaters in Sub-Saharan Africa (developing only) in 2006 to that in 2011?
Ensure brevity in your answer.  1.02. What is the ratio of the % of repeaters of Indonesia in 2006 to that in 2011?
Offer a very short reply. 1.42. What is the ratio of the % of repeaters of Mauritius in 2006 to that in 2011?
Make the answer very short. 1.14. What is the ratio of the % of repeaters in Small states in 2007 to that in 2008?
Keep it short and to the point. 0.99. What is the ratio of the % of repeaters of Indonesia in 2007 to that in 2008?
Offer a very short reply. 0.84. What is the ratio of the % of repeaters of Mauritius in 2007 to that in 2008?
Keep it short and to the point. 0.97. What is the ratio of the % of repeaters in Small states in 2007 to that in 2009?
Provide a short and direct response. 0.98. What is the ratio of the % of repeaters in Sub-Saharan Africa (developing only) in 2007 to that in 2009?
Your answer should be very brief. 0.97. What is the ratio of the % of repeaters of Indonesia in 2007 to that in 2009?
Provide a short and direct response. 0.69. What is the ratio of the % of repeaters in Mauritius in 2007 to that in 2009?
Your answer should be very brief. 0.96. What is the ratio of the % of repeaters in Indonesia in 2007 to that in 2010?
Your response must be concise. 0.88. What is the ratio of the % of repeaters of Mauritius in 2007 to that in 2010?
Offer a very short reply. 0.94. What is the ratio of the % of repeaters in Small states in 2007 to that in 2011?
Provide a succinct answer. 0.96. What is the ratio of the % of repeaters in Sub-Saharan Africa (developing only) in 2007 to that in 2011?
Ensure brevity in your answer.  1.01. What is the ratio of the % of repeaters of Indonesia in 2007 to that in 2011?
Your answer should be very brief. 1.11. What is the ratio of the % of repeaters of Mauritius in 2007 to that in 2011?
Your answer should be compact. 1.04. What is the ratio of the % of repeaters in Small states in 2008 to that in 2009?
Ensure brevity in your answer.  0.99. What is the ratio of the % of repeaters of Sub-Saharan Africa (developing only) in 2008 to that in 2009?
Ensure brevity in your answer.  0.97. What is the ratio of the % of repeaters of Indonesia in 2008 to that in 2009?
Your answer should be very brief. 0.83. What is the ratio of the % of repeaters of Sub-Saharan Africa (developing only) in 2008 to that in 2010?
Your answer should be compact. 0.99. What is the ratio of the % of repeaters of Indonesia in 2008 to that in 2010?
Give a very brief answer. 1.05. What is the ratio of the % of repeaters of Mauritius in 2008 to that in 2010?
Your response must be concise. 0.97. What is the ratio of the % of repeaters of Small states in 2008 to that in 2011?
Your answer should be very brief. 0.97. What is the ratio of the % of repeaters of Sub-Saharan Africa (developing only) in 2008 to that in 2011?
Give a very brief answer. 1.01. What is the ratio of the % of repeaters in Indonesia in 2008 to that in 2011?
Your answer should be compact. 1.33. What is the ratio of the % of repeaters in Mauritius in 2008 to that in 2011?
Provide a succinct answer. 1.07. What is the ratio of the % of repeaters of Small states in 2009 to that in 2010?
Your answer should be compact. 0.98. What is the ratio of the % of repeaters in Sub-Saharan Africa (developing only) in 2009 to that in 2010?
Offer a very short reply. 1.02. What is the ratio of the % of repeaters of Indonesia in 2009 to that in 2010?
Your answer should be compact. 1.27. What is the ratio of the % of repeaters of Mauritius in 2009 to that in 2010?
Keep it short and to the point. 0.98. What is the ratio of the % of repeaters of Small states in 2009 to that in 2011?
Give a very brief answer. 0.99. What is the ratio of the % of repeaters of Sub-Saharan Africa (developing only) in 2009 to that in 2011?
Make the answer very short. 1.05. What is the ratio of the % of repeaters of Indonesia in 2009 to that in 2011?
Offer a very short reply. 1.6. What is the ratio of the % of repeaters in Mauritius in 2009 to that in 2011?
Your response must be concise. 1.08. What is the ratio of the % of repeaters in Sub-Saharan Africa (developing only) in 2010 to that in 2011?
Give a very brief answer. 1.02. What is the ratio of the % of repeaters in Indonesia in 2010 to that in 2011?
Make the answer very short. 1.26. What is the ratio of the % of repeaters of Mauritius in 2010 to that in 2011?
Offer a terse response. 1.1. What is the difference between the highest and the second highest % of repeaters in Sub-Saharan Africa (developing only)?
Offer a very short reply. 0.08. What is the difference between the highest and the second highest % of repeaters of Indonesia?
Offer a terse response. 0.04. What is the difference between the highest and the second highest % of repeaters in Mauritius?
Your answer should be compact. 0.37. What is the difference between the highest and the lowest % of repeaters of Small states?
Your answer should be very brief. 0.4. What is the difference between the highest and the lowest % of repeaters in Sub-Saharan Africa (developing only)?
Provide a succinct answer. 0.53. What is the difference between the highest and the lowest % of repeaters of Indonesia?
Provide a succinct answer. 0.15. What is the difference between the highest and the lowest % of repeaters in Mauritius?
Make the answer very short. 1.32. 